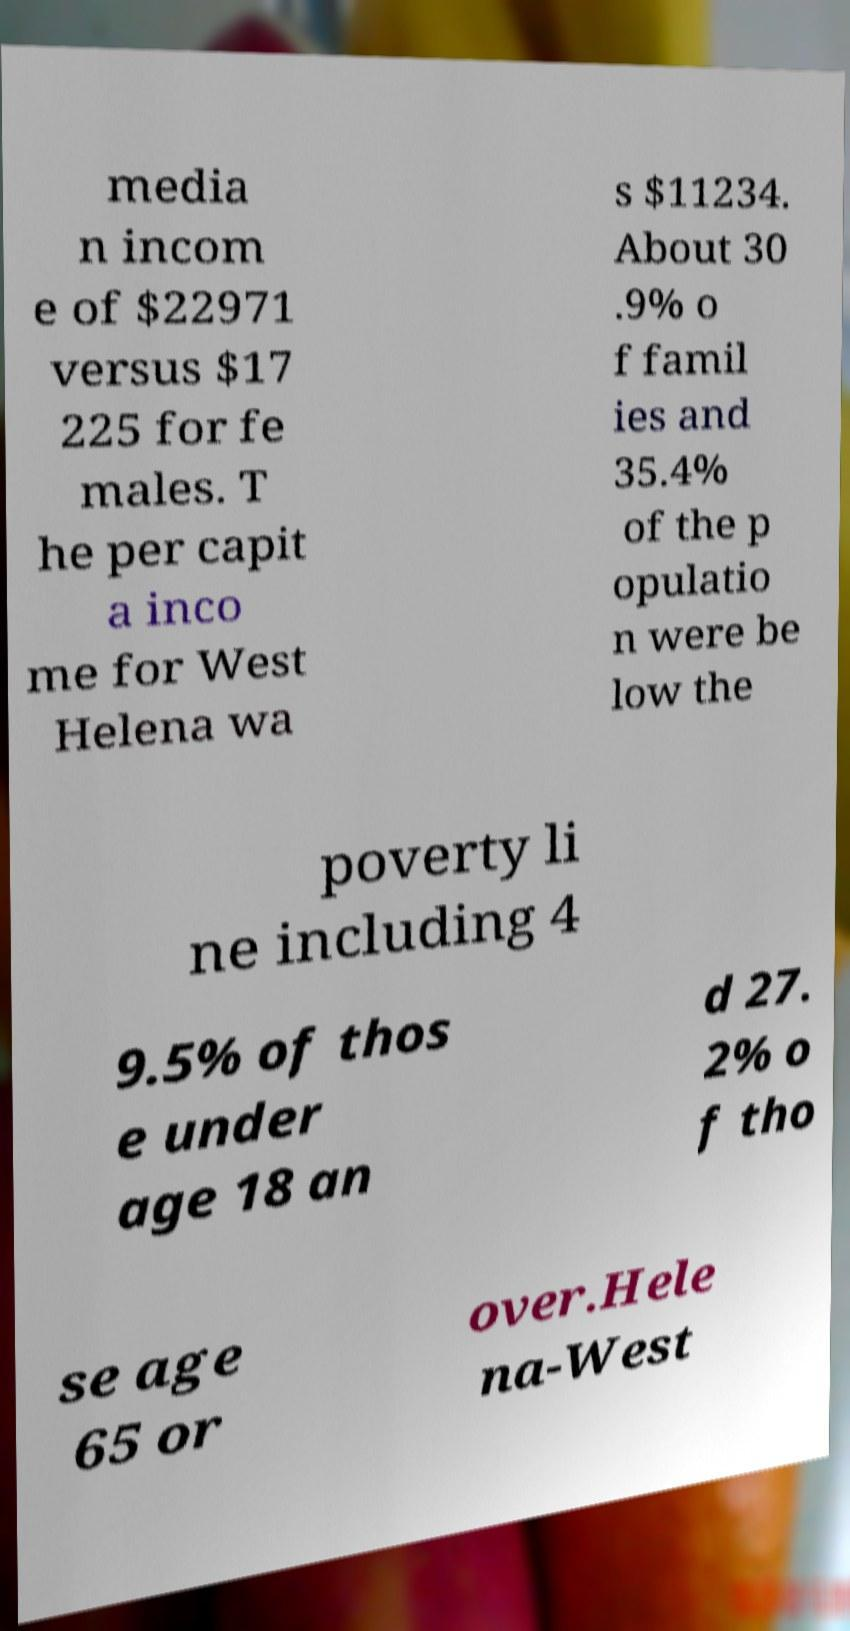I need the written content from this picture converted into text. Can you do that? media n incom e of $22971 versus $17 225 for fe males. T he per capit a inco me for West Helena wa s $11234. About 30 .9% o f famil ies and 35.4% of the p opulatio n were be low the poverty li ne including 4 9.5% of thos e under age 18 an d 27. 2% o f tho se age 65 or over.Hele na-West 